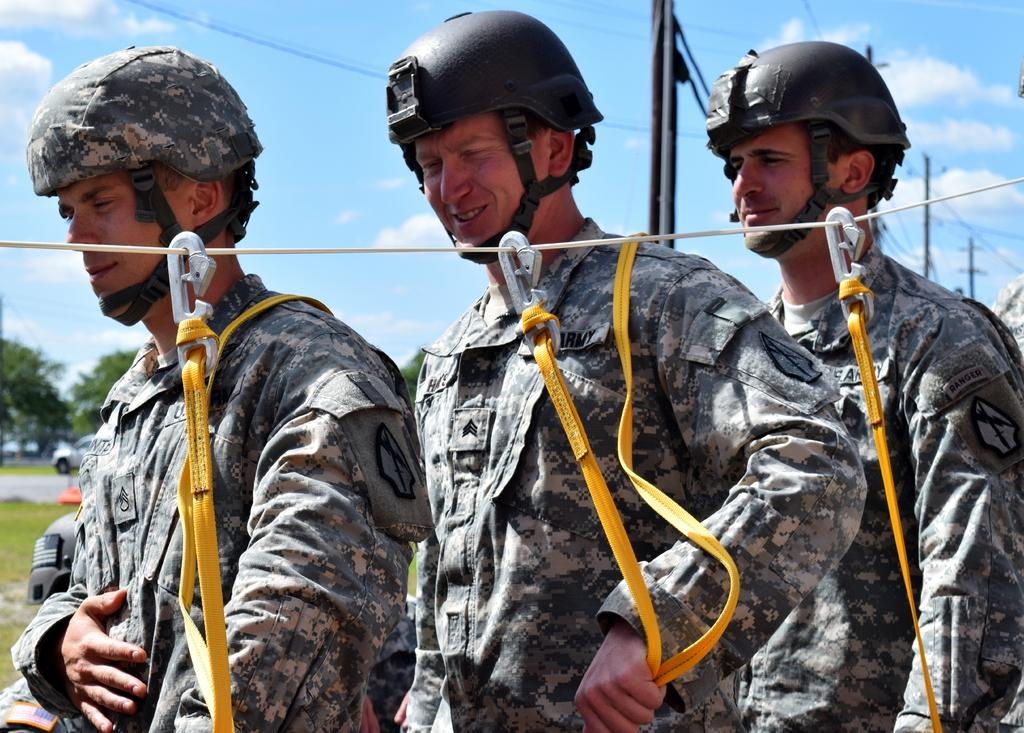How many people are in the image? There are three people in the image. What are the people wearing? The people are wearing military uniforms and helmets. What is the weather like in the image? The sky is cloudy in the image. What can be seen in the background of the image? There are trees, a pole, and a vehicle in the background of the image. What type of curtain can be seen hanging from the pole in the image? There is no curtain present in the image; the pole is in the background of the image without any curtains hanging from it. 